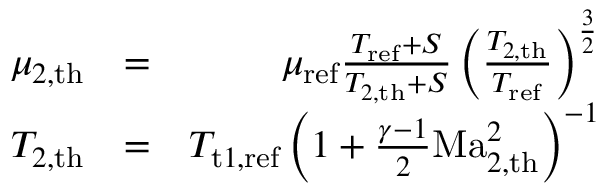Convert formula to latex. <formula><loc_0><loc_0><loc_500><loc_500>\begin{array} { r l r } { \mu _ { 2 , t h } } & { = } & { \mu _ { r e f } \frac { T _ { r e f } + S } { T _ { 2 , t h } + S } \left ( \frac { T _ { 2 , t h } } { T _ { r e f } } \right ) ^ { \frac { 3 } { 2 } } } \\ { T _ { 2 , t h } } & { = } & { T _ { t 1 , r e f } \left ( 1 + \frac { \gamma - 1 } { 2 } M a _ { 2 , t h } ^ { 2 } \right ) ^ { - 1 } } \end{array}</formula> 